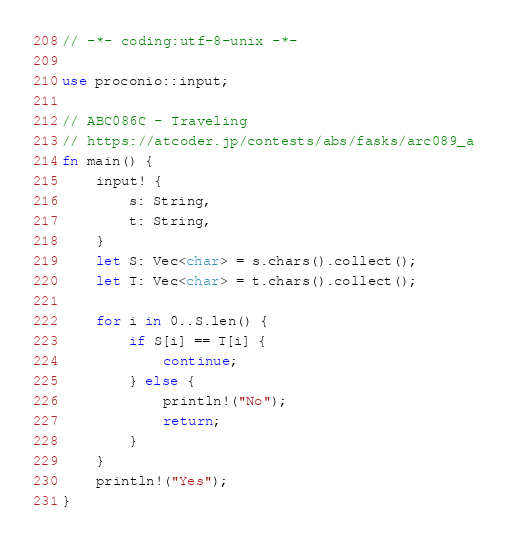Convert code to text. <code><loc_0><loc_0><loc_500><loc_500><_Rust_>// -*- coding:utf-8-unix -*-

use proconio::input;

// ABC086C - Traveling
// https://atcoder.jp/contests/abs/fasks/arc089_a
fn main() {
    input! {
        s: String,
        t: String,
    }
    let S: Vec<char> = s.chars().collect();
    let T: Vec<char> = t.chars().collect();

    for i in 0..S.len() {
        if S[i] == T[i] {
            continue;
        } else {
            println!("No");
            return;
        }
    }
    println!("Yes");
}
</code> 